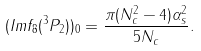<formula> <loc_0><loc_0><loc_500><loc_500>( I m f _ { 8 } ( ^ { 3 } P _ { 2 } ) ) _ { 0 } = \frac { \pi ( N _ { c } ^ { 2 } - 4 ) \alpha _ { s } ^ { 2 } } { 5 N _ { c } } .</formula> 